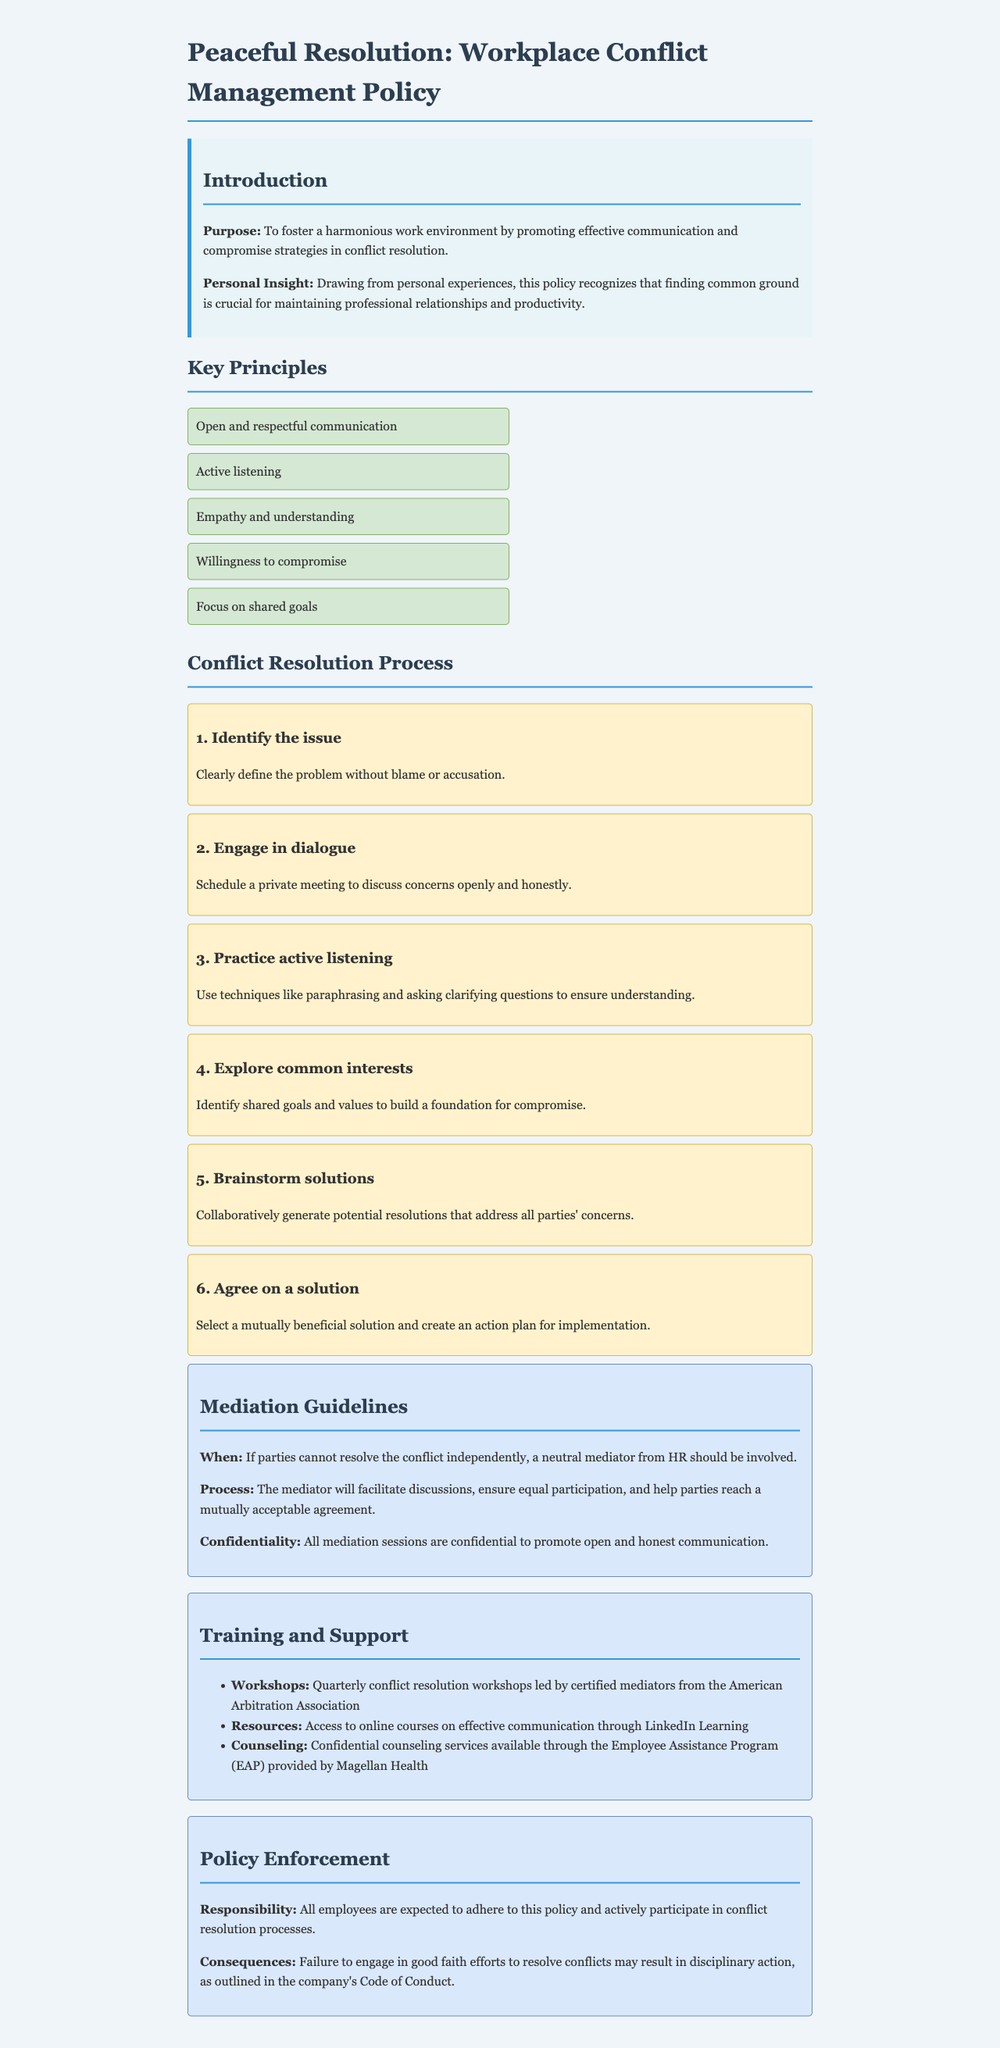What is the purpose of the policy? The purpose is defined in the introduction section, focusing on effective communication and compromise strategies in conflict resolution.
Answer: To foster a harmonious work environment by promoting effective communication and compromise strategies in conflict resolution How many key principles are there? The number of key principles is found in the section titled "Key Principles."
Answer: Five What is the first step in the conflict resolution process? The first step is outlined in the section "Conflict Resolution Process" and is the initial action required to address conflicts.
Answer: Identify the issue Which organization leads the quarterly conflict resolution workshops? The organization responsible for the workshops is mentioned under the training section.
Answer: American Arbitration Association What happens if parties cannot resolve the conflict independently? The protocol for unresolved conflicts is described in the mediation guidelines section.
Answer: A neutral mediator from HR should be involved What should all employees do according to the policy enforcement section? The responsibilities of employees are clearly stated in the enforcement section of the document.
Answer: Adhere to this policy and actively participate in conflict resolution processes 